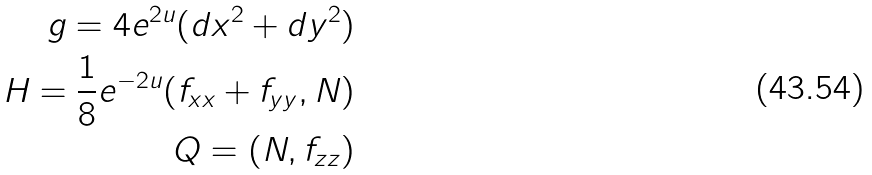<formula> <loc_0><loc_0><loc_500><loc_500>g = 4 e ^ { 2 u } ( d x ^ { 2 } + d y ^ { 2 } ) \\ H = \frac { 1 } { 8 } e ^ { - 2 u } ( f _ { x x } + f _ { y y } , N ) \\ Q = ( N , f _ { z z } )</formula> 